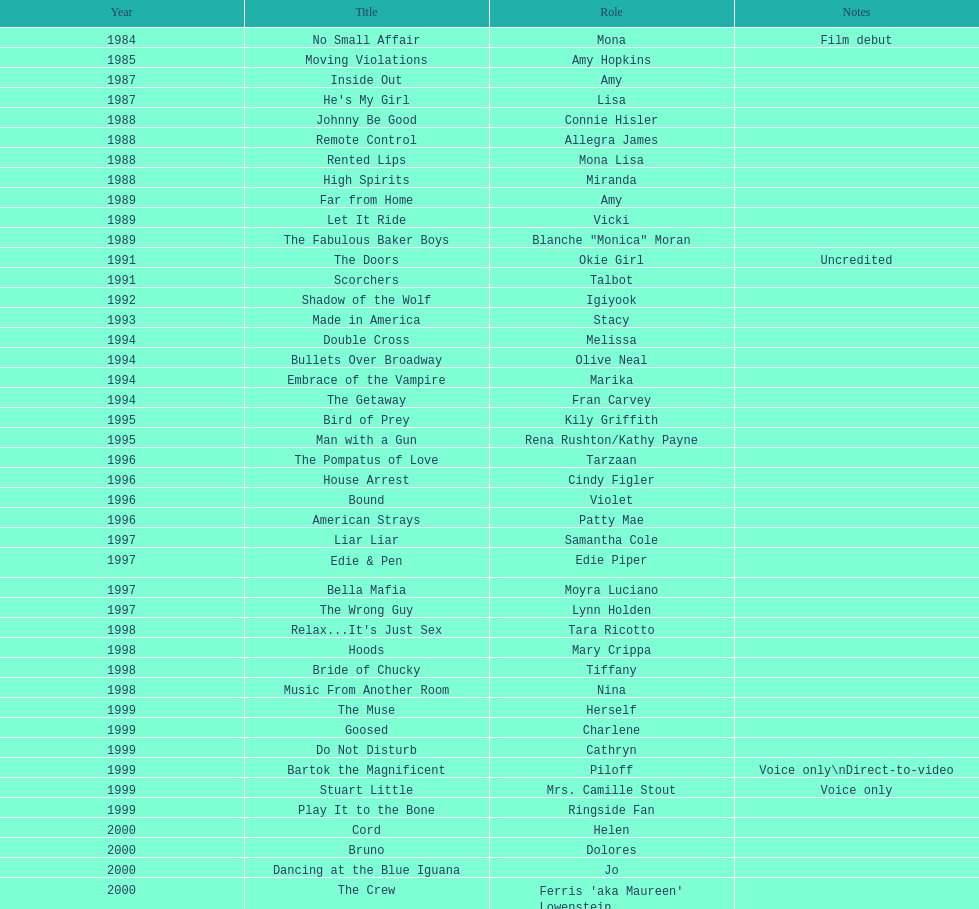How many voice-over roles in films has jennifer tilly participated in? 5. 